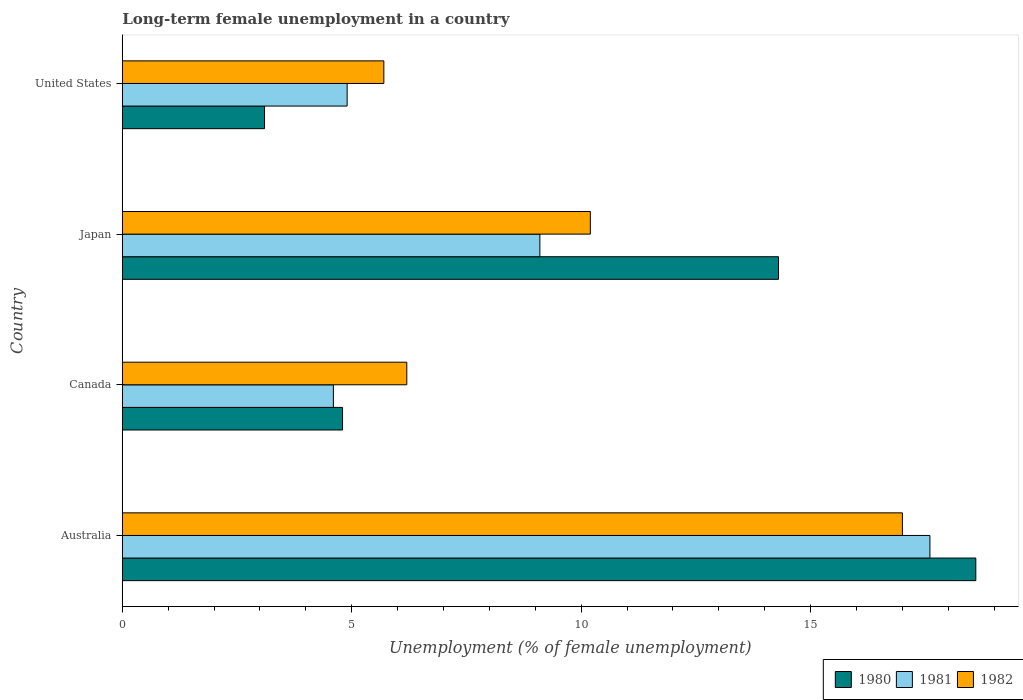How many different coloured bars are there?
Give a very brief answer. 3. Are the number of bars per tick equal to the number of legend labels?
Make the answer very short. Yes. How many bars are there on the 3rd tick from the top?
Provide a succinct answer. 3. How many bars are there on the 1st tick from the bottom?
Keep it short and to the point. 3. What is the label of the 3rd group of bars from the top?
Your response must be concise. Canada. In how many cases, is the number of bars for a given country not equal to the number of legend labels?
Your response must be concise. 0. What is the percentage of long-term unemployed female population in 1981 in Australia?
Provide a succinct answer. 17.6. Across all countries, what is the maximum percentage of long-term unemployed female population in 1980?
Provide a short and direct response. 18.6. Across all countries, what is the minimum percentage of long-term unemployed female population in 1982?
Your answer should be very brief. 5.7. What is the total percentage of long-term unemployed female population in 1982 in the graph?
Provide a short and direct response. 39.1. What is the difference between the percentage of long-term unemployed female population in 1982 in Canada and that in Japan?
Offer a terse response. -4. What is the difference between the percentage of long-term unemployed female population in 1982 in United States and the percentage of long-term unemployed female population in 1981 in Australia?
Make the answer very short. -11.9. What is the average percentage of long-term unemployed female population in 1980 per country?
Your response must be concise. 10.2. What is the difference between the percentage of long-term unemployed female population in 1980 and percentage of long-term unemployed female population in 1982 in Canada?
Your response must be concise. -1.4. In how many countries, is the percentage of long-term unemployed female population in 1981 greater than 17 %?
Keep it short and to the point. 1. What is the ratio of the percentage of long-term unemployed female population in 1981 in Australia to that in United States?
Offer a very short reply. 3.59. What is the difference between the highest and the second highest percentage of long-term unemployed female population in 1981?
Provide a succinct answer. 8.5. What is the difference between the highest and the lowest percentage of long-term unemployed female population in 1982?
Provide a succinct answer. 11.3. In how many countries, is the percentage of long-term unemployed female population in 1981 greater than the average percentage of long-term unemployed female population in 1981 taken over all countries?
Provide a succinct answer. 2. What does the 2nd bar from the bottom in Australia represents?
Offer a very short reply. 1981. How many bars are there?
Offer a very short reply. 12. Are all the bars in the graph horizontal?
Keep it short and to the point. Yes. How many countries are there in the graph?
Ensure brevity in your answer.  4. What is the difference between two consecutive major ticks on the X-axis?
Make the answer very short. 5. Are the values on the major ticks of X-axis written in scientific E-notation?
Offer a terse response. No. Where does the legend appear in the graph?
Your answer should be very brief. Bottom right. How are the legend labels stacked?
Your answer should be very brief. Horizontal. What is the title of the graph?
Keep it short and to the point. Long-term female unemployment in a country. Does "1990" appear as one of the legend labels in the graph?
Provide a short and direct response. No. What is the label or title of the X-axis?
Make the answer very short. Unemployment (% of female unemployment). What is the label or title of the Y-axis?
Offer a very short reply. Country. What is the Unemployment (% of female unemployment) of 1980 in Australia?
Keep it short and to the point. 18.6. What is the Unemployment (% of female unemployment) of 1981 in Australia?
Make the answer very short. 17.6. What is the Unemployment (% of female unemployment) of 1980 in Canada?
Make the answer very short. 4.8. What is the Unemployment (% of female unemployment) of 1981 in Canada?
Make the answer very short. 4.6. What is the Unemployment (% of female unemployment) in 1982 in Canada?
Make the answer very short. 6.2. What is the Unemployment (% of female unemployment) in 1980 in Japan?
Provide a succinct answer. 14.3. What is the Unemployment (% of female unemployment) of 1981 in Japan?
Provide a short and direct response. 9.1. What is the Unemployment (% of female unemployment) in 1982 in Japan?
Your answer should be very brief. 10.2. What is the Unemployment (% of female unemployment) in 1980 in United States?
Your response must be concise. 3.1. What is the Unemployment (% of female unemployment) of 1981 in United States?
Make the answer very short. 4.9. What is the Unemployment (% of female unemployment) in 1982 in United States?
Keep it short and to the point. 5.7. Across all countries, what is the maximum Unemployment (% of female unemployment) in 1980?
Keep it short and to the point. 18.6. Across all countries, what is the maximum Unemployment (% of female unemployment) of 1981?
Keep it short and to the point. 17.6. Across all countries, what is the minimum Unemployment (% of female unemployment) in 1980?
Your answer should be compact. 3.1. Across all countries, what is the minimum Unemployment (% of female unemployment) in 1981?
Your answer should be compact. 4.6. Across all countries, what is the minimum Unemployment (% of female unemployment) of 1982?
Your answer should be compact. 5.7. What is the total Unemployment (% of female unemployment) of 1980 in the graph?
Your answer should be very brief. 40.8. What is the total Unemployment (% of female unemployment) in 1981 in the graph?
Offer a terse response. 36.2. What is the total Unemployment (% of female unemployment) in 1982 in the graph?
Give a very brief answer. 39.1. What is the difference between the Unemployment (% of female unemployment) of 1980 in Australia and that in Canada?
Ensure brevity in your answer.  13.8. What is the difference between the Unemployment (% of female unemployment) of 1980 in Australia and that in Japan?
Your answer should be compact. 4.3. What is the difference between the Unemployment (% of female unemployment) in 1981 in Australia and that in Japan?
Your answer should be compact. 8.5. What is the difference between the Unemployment (% of female unemployment) in 1982 in Australia and that in United States?
Offer a very short reply. 11.3. What is the difference between the Unemployment (% of female unemployment) in 1980 in Canada and that in Japan?
Your response must be concise. -9.5. What is the difference between the Unemployment (% of female unemployment) in 1980 in Canada and that in United States?
Provide a short and direct response. 1.7. What is the difference between the Unemployment (% of female unemployment) in 1981 in Canada and that in United States?
Give a very brief answer. -0.3. What is the difference between the Unemployment (% of female unemployment) of 1980 in Japan and that in United States?
Provide a succinct answer. 11.2. What is the difference between the Unemployment (% of female unemployment) in 1981 in Japan and that in United States?
Offer a terse response. 4.2. What is the difference between the Unemployment (% of female unemployment) of 1982 in Japan and that in United States?
Your answer should be compact. 4.5. What is the difference between the Unemployment (% of female unemployment) of 1980 in Australia and the Unemployment (% of female unemployment) of 1982 in Canada?
Your answer should be compact. 12.4. What is the difference between the Unemployment (% of female unemployment) of 1980 in Australia and the Unemployment (% of female unemployment) of 1981 in Japan?
Make the answer very short. 9.5. What is the difference between the Unemployment (% of female unemployment) in 1980 in Australia and the Unemployment (% of female unemployment) in 1982 in Japan?
Your answer should be very brief. 8.4. What is the difference between the Unemployment (% of female unemployment) of 1981 in Australia and the Unemployment (% of female unemployment) of 1982 in United States?
Ensure brevity in your answer.  11.9. What is the difference between the Unemployment (% of female unemployment) of 1980 in Canada and the Unemployment (% of female unemployment) of 1981 in Japan?
Keep it short and to the point. -4.3. What is the difference between the Unemployment (% of female unemployment) of 1981 in Canada and the Unemployment (% of female unemployment) of 1982 in United States?
Make the answer very short. -1.1. What is the difference between the Unemployment (% of female unemployment) in 1980 in Japan and the Unemployment (% of female unemployment) in 1982 in United States?
Your answer should be compact. 8.6. What is the average Unemployment (% of female unemployment) of 1980 per country?
Give a very brief answer. 10.2. What is the average Unemployment (% of female unemployment) in 1981 per country?
Give a very brief answer. 9.05. What is the average Unemployment (% of female unemployment) in 1982 per country?
Provide a short and direct response. 9.78. What is the difference between the Unemployment (% of female unemployment) in 1980 and Unemployment (% of female unemployment) in 1981 in Australia?
Ensure brevity in your answer.  1. What is the difference between the Unemployment (% of female unemployment) in 1980 and Unemployment (% of female unemployment) in 1982 in Australia?
Give a very brief answer. 1.6. What is the difference between the Unemployment (% of female unemployment) of 1981 and Unemployment (% of female unemployment) of 1982 in Canada?
Your answer should be very brief. -1.6. What is the difference between the Unemployment (% of female unemployment) in 1980 and Unemployment (% of female unemployment) in 1982 in Japan?
Make the answer very short. 4.1. What is the difference between the Unemployment (% of female unemployment) of 1980 and Unemployment (% of female unemployment) of 1981 in United States?
Provide a short and direct response. -1.8. What is the difference between the Unemployment (% of female unemployment) in 1980 and Unemployment (% of female unemployment) in 1982 in United States?
Provide a short and direct response. -2.6. What is the ratio of the Unemployment (% of female unemployment) of 1980 in Australia to that in Canada?
Give a very brief answer. 3.88. What is the ratio of the Unemployment (% of female unemployment) of 1981 in Australia to that in Canada?
Offer a very short reply. 3.83. What is the ratio of the Unemployment (% of female unemployment) of 1982 in Australia to that in Canada?
Make the answer very short. 2.74. What is the ratio of the Unemployment (% of female unemployment) in 1980 in Australia to that in Japan?
Provide a succinct answer. 1.3. What is the ratio of the Unemployment (% of female unemployment) in 1981 in Australia to that in Japan?
Ensure brevity in your answer.  1.93. What is the ratio of the Unemployment (% of female unemployment) of 1982 in Australia to that in Japan?
Your answer should be very brief. 1.67. What is the ratio of the Unemployment (% of female unemployment) in 1980 in Australia to that in United States?
Your response must be concise. 6. What is the ratio of the Unemployment (% of female unemployment) in 1981 in Australia to that in United States?
Ensure brevity in your answer.  3.59. What is the ratio of the Unemployment (% of female unemployment) of 1982 in Australia to that in United States?
Ensure brevity in your answer.  2.98. What is the ratio of the Unemployment (% of female unemployment) of 1980 in Canada to that in Japan?
Provide a succinct answer. 0.34. What is the ratio of the Unemployment (% of female unemployment) of 1981 in Canada to that in Japan?
Provide a succinct answer. 0.51. What is the ratio of the Unemployment (% of female unemployment) of 1982 in Canada to that in Japan?
Your response must be concise. 0.61. What is the ratio of the Unemployment (% of female unemployment) of 1980 in Canada to that in United States?
Ensure brevity in your answer.  1.55. What is the ratio of the Unemployment (% of female unemployment) of 1981 in Canada to that in United States?
Your response must be concise. 0.94. What is the ratio of the Unemployment (% of female unemployment) of 1982 in Canada to that in United States?
Provide a succinct answer. 1.09. What is the ratio of the Unemployment (% of female unemployment) in 1980 in Japan to that in United States?
Your answer should be compact. 4.61. What is the ratio of the Unemployment (% of female unemployment) in 1981 in Japan to that in United States?
Make the answer very short. 1.86. What is the ratio of the Unemployment (% of female unemployment) in 1982 in Japan to that in United States?
Your answer should be compact. 1.79. What is the difference between the highest and the second highest Unemployment (% of female unemployment) in 1980?
Your response must be concise. 4.3. What is the difference between the highest and the lowest Unemployment (% of female unemployment) of 1981?
Your answer should be very brief. 13. What is the difference between the highest and the lowest Unemployment (% of female unemployment) of 1982?
Provide a succinct answer. 11.3. 